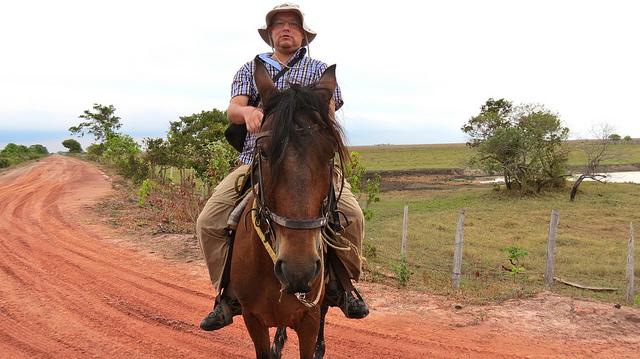Is the man riding side-saddle?
Keep it brief. No. Does the man look like he's having fun?
Quick response, please. No. Is this person traveling by horse?
Short answer required. Yes. 